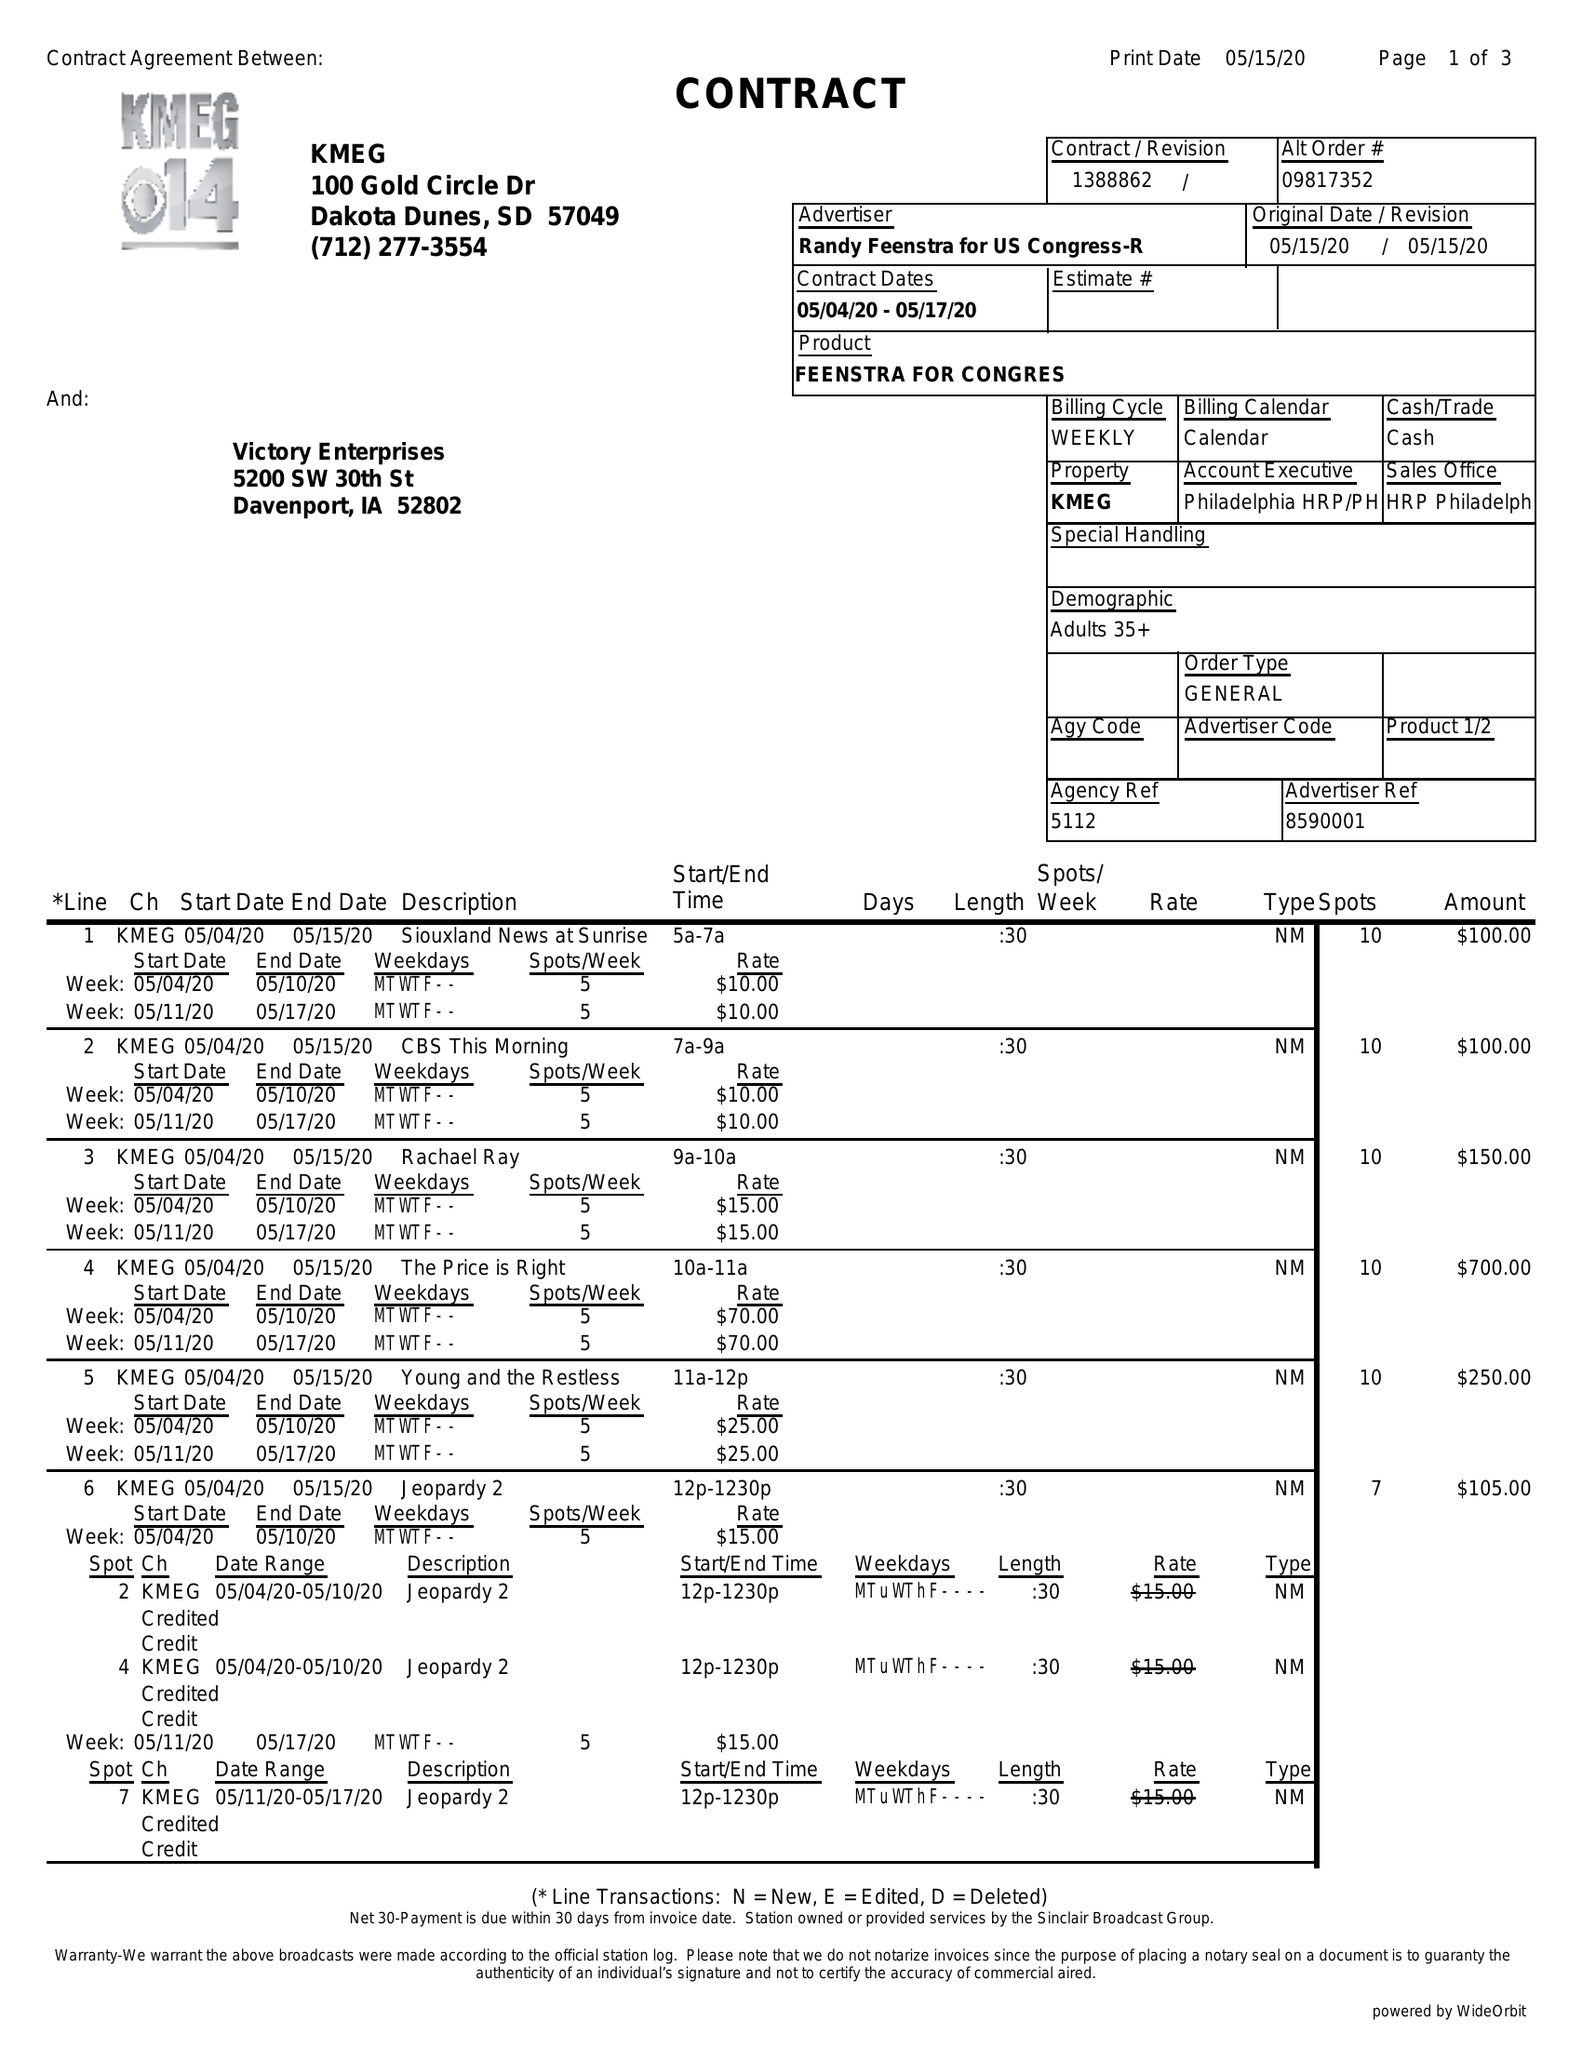What is the value for the flight_from?
Answer the question using a single word or phrase. 05/04/20 